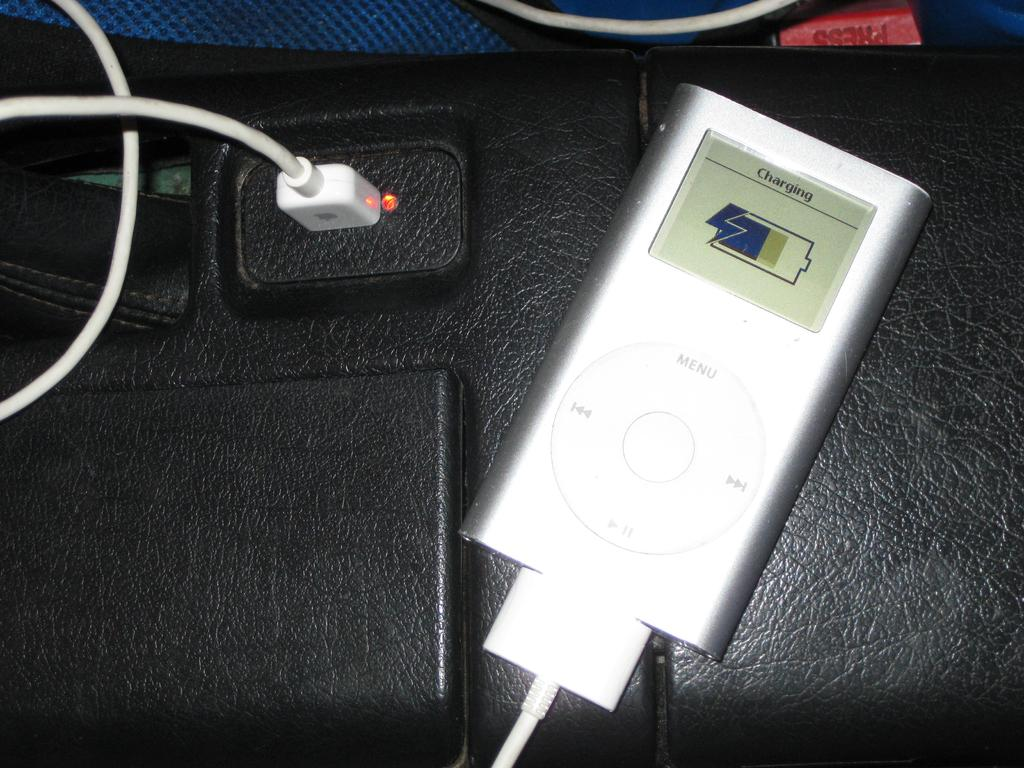What electronic device is visible in the image? There is an iPod in the image. What is connected to the iPod in the image? There is a charger in the image, which is connected to the iPod. What is used to connect the charger to the iPod? There is a wire in the image, which is used to connect the charger to the iPod. Where is the charger plugged in? There is a socket in the image, where the charger is plugged in. What indicates the power status of the charger? There is an LED light in the image, which indicates the power status of the charger. What is the purpose of the button in the image? The button in the image is likely used to control the iPod or the charger. What type of mint is growing in the image? There is no mint plant or any reference to mint in the image. 